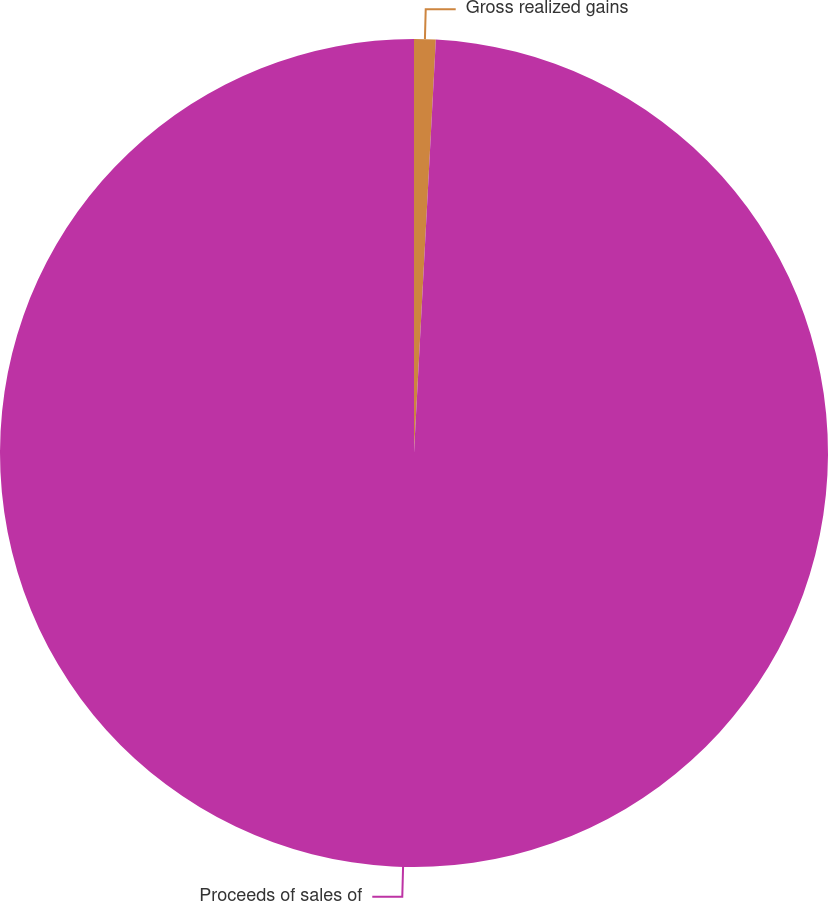Convert chart. <chart><loc_0><loc_0><loc_500><loc_500><pie_chart><fcel>Gross realized gains<fcel>Proceeds of sales of<nl><fcel>0.84%<fcel>99.16%<nl></chart> 